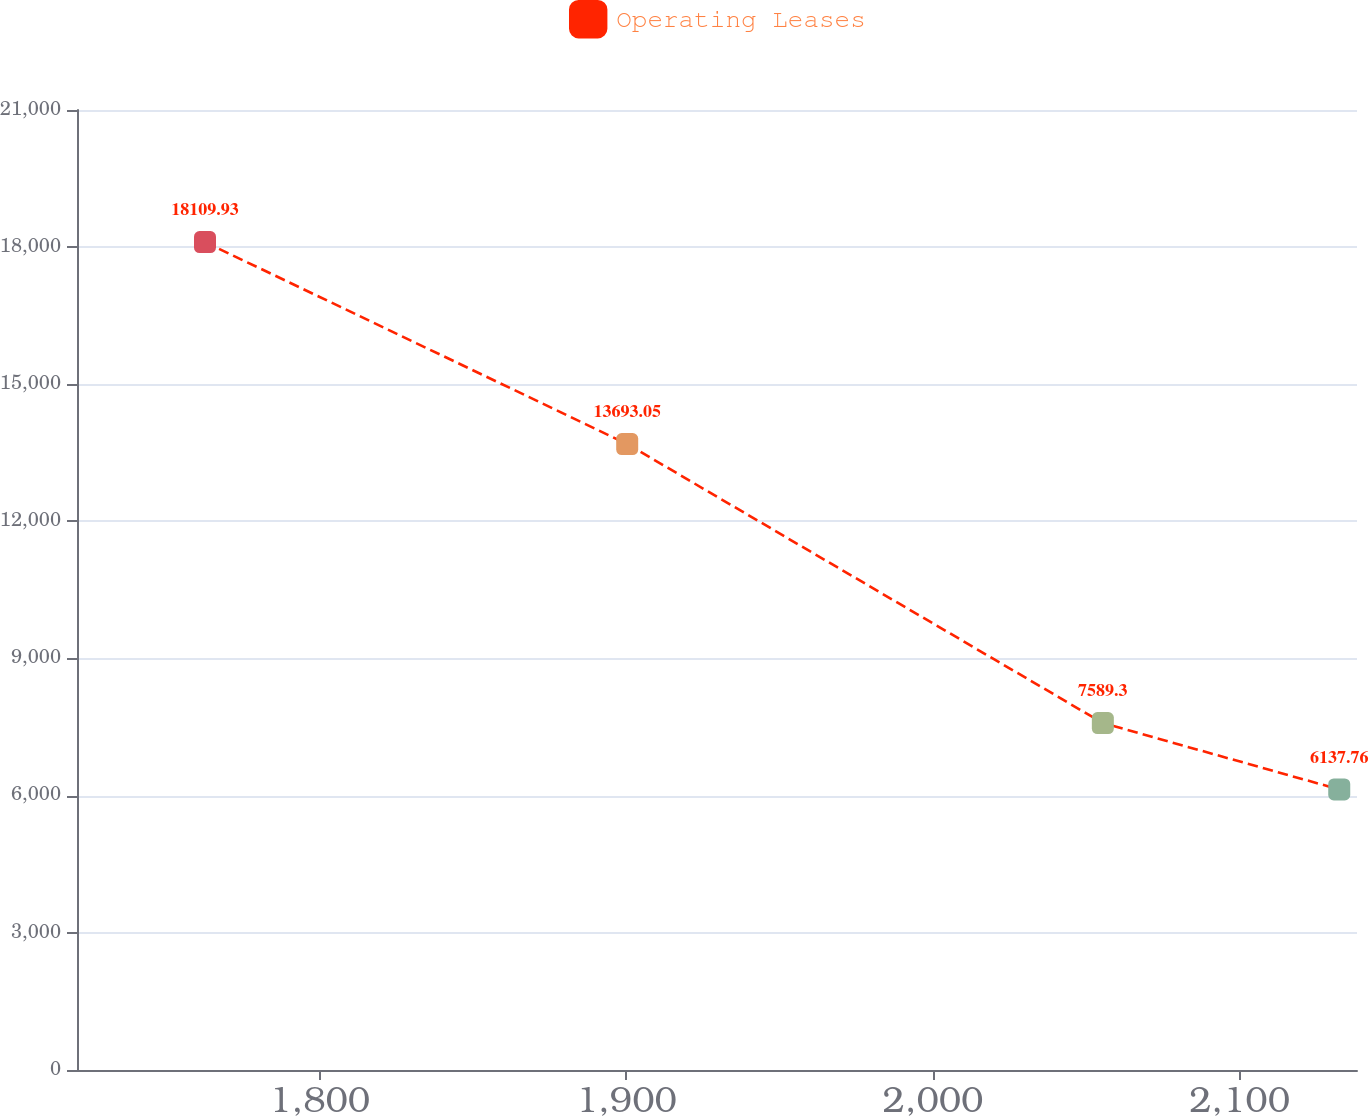Convert chart. <chart><loc_0><loc_0><loc_500><loc_500><line_chart><ecel><fcel>Operating Leases<nl><fcel>1762.57<fcel>18109.9<nl><fcel>1900.27<fcel>13693<nl><fcel>2055.4<fcel>7589.3<nl><fcel>2132.5<fcel>6137.76<nl><fcel>2180.04<fcel>3594.51<nl></chart> 